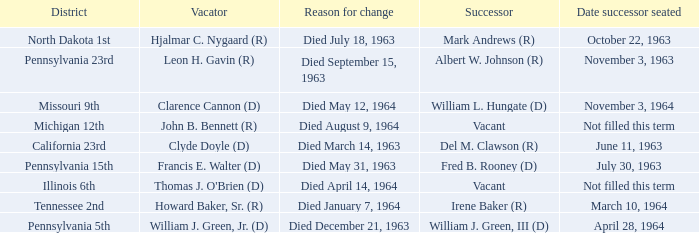What is every district for reason for change is died August 9, 1964? Michigan 12th. 